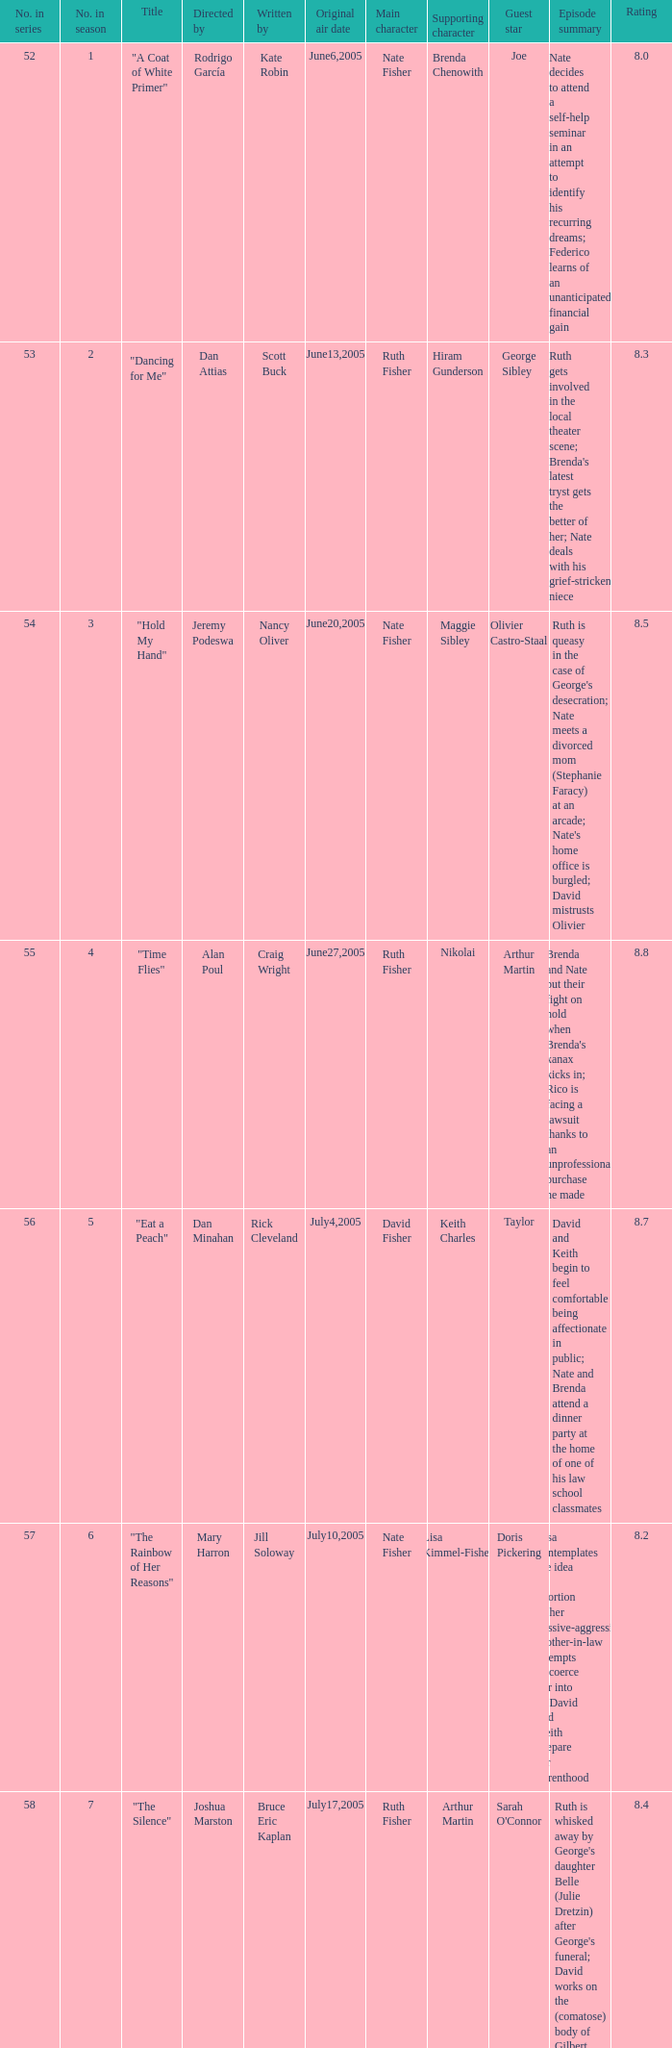What was the name of the episode that was directed by Mary Harron? "The Rainbow of Her Reasons". 